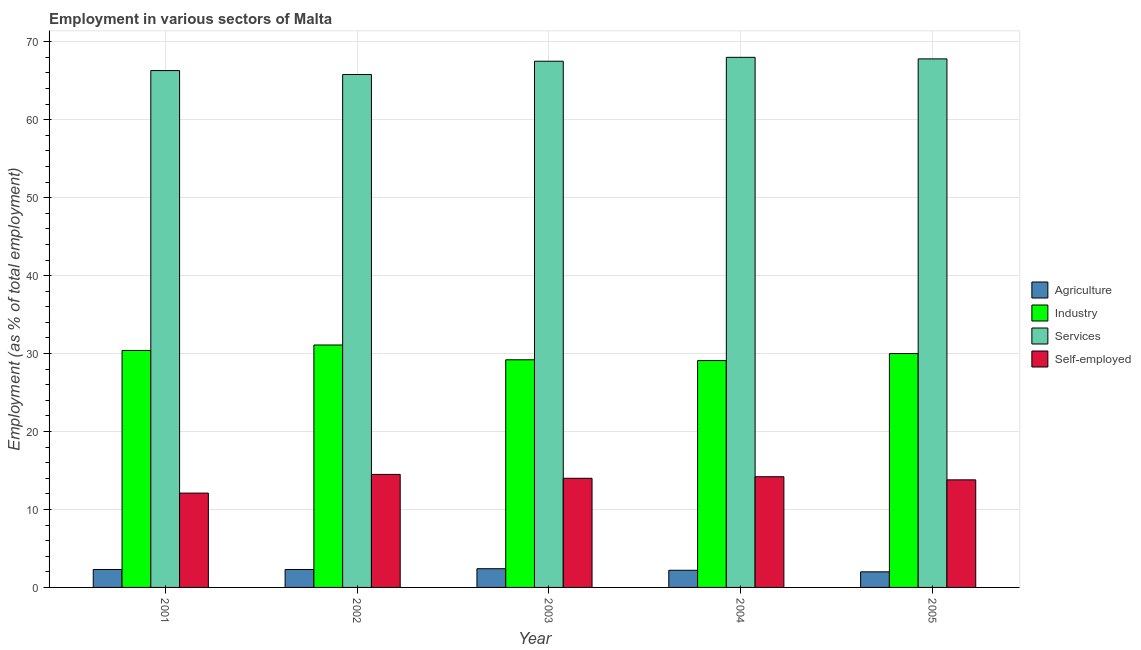How many different coloured bars are there?
Offer a terse response. 4. How many groups of bars are there?
Your response must be concise. 5. Are the number of bars per tick equal to the number of legend labels?
Provide a succinct answer. Yes. How many bars are there on the 2nd tick from the left?
Ensure brevity in your answer.  4. How many bars are there on the 1st tick from the right?
Your answer should be compact. 4. In how many cases, is the number of bars for a given year not equal to the number of legend labels?
Offer a very short reply. 0. What is the percentage of self employed workers in 2004?
Offer a very short reply. 14.2. Across all years, what is the maximum percentage of workers in industry?
Provide a succinct answer. 31.1. Across all years, what is the minimum percentage of self employed workers?
Your answer should be compact. 12.1. What is the total percentage of workers in services in the graph?
Make the answer very short. 335.4. What is the difference between the percentage of workers in agriculture in 2001 and that in 2005?
Your answer should be compact. 0.3. What is the difference between the percentage of workers in services in 2005 and the percentage of workers in industry in 2001?
Keep it short and to the point. 1.5. What is the average percentage of self employed workers per year?
Ensure brevity in your answer.  13.72. In the year 2003, what is the difference between the percentage of workers in agriculture and percentage of workers in industry?
Provide a short and direct response. 0. What is the ratio of the percentage of self employed workers in 2003 to that in 2004?
Offer a terse response. 0.99. Is the percentage of self employed workers in 2001 less than that in 2005?
Ensure brevity in your answer.  Yes. Is the difference between the percentage of workers in industry in 2001 and 2004 greater than the difference between the percentage of self employed workers in 2001 and 2004?
Offer a very short reply. No. What is the difference between the highest and the second highest percentage of self employed workers?
Your response must be concise. 0.3. What is the difference between the highest and the lowest percentage of workers in industry?
Ensure brevity in your answer.  2. What does the 2nd bar from the left in 2001 represents?
Keep it short and to the point. Industry. What does the 3rd bar from the right in 2003 represents?
Offer a very short reply. Industry. Is it the case that in every year, the sum of the percentage of workers in agriculture and percentage of workers in industry is greater than the percentage of workers in services?
Ensure brevity in your answer.  No. Are the values on the major ticks of Y-axis written in scientific E-notation?
Offer a very short reply. No. How are the legend labels stacked?
Provide a short and direct response. Vertical. What is the title of the graph?
Your answer should be compact. Employment in various sectors of Malta. What is the label or title of the X-axis?
Give a very brief answer. Year. What is the label or title of the Y-axis?
Make the answer very short. Employment (as % of total employment). What is the Employment (as % of total employment) in Agriculture in 2001?
Make the answer very short. 2.3. What is the Employment (as % of total employment) in Industry in 2001?
Your answer should be very brief. 30.4. What is the Employment (as % of total employment) of Services in 2001?
Your answer should be compact. 66.3. What is the Employment (as % of total employment) in Self-employed in 2001?
Offer a terse response. 12.1. What is the Employment (as % of total employment) in Agriculture in 2002?
Offer a terse response. 2.3. What is the Employment (as % of total employment) in Industry in 2002?
Offer a very short reply. 31.1. What is the Employment (as % of total employment) of Services in 2002?
Keep it short and to the point. 65.8. What is the Employment (as % of total employment) in Self-employed in 2002?
Give a very brief answer. 14.5. What is the Employment (as % of total employment) in Agriculture in 2003?
Offer a very short reply. 2.4. What is the Employment (as % of total employment) of Industry in 2003?
Offer a terse response. 29.2. What is the Employment (as % of total employment) of Services in 2003?
Provide a succinct answer. 67.5. What is the Employment (as % of total employment) of Agriculture in 2004?
Give a very brief answer. 2.2. What is the Employment (as % of total employment) of Industry in 2004?
Provide a short and direct response. 29.1. What is the Employment (as % of total employment) of Self-employed in 2004?
Offer a terse response. 14.2. What is the Employment (as % of total employment) of Industry in 2005?
Offer a terse response. 30. What is the Employment (as % of total employment) of Services in 2005?
Offer a terse response. 67.8. What is the Employment (as % of total employment) of Self-employed in 2005?
Keep it short and to the point. 13.8. Across all years, what is the maximum Employment (as % of total employment) in Agriculture?
Ensure brevity in your answer.  2.4. Across all years, what is the maximum Employment (as % of total employment) in Industry?
Your answer should be very brief. 31.1. Across all years, what is the minimum Employment (as % of total employment) in Agriculture?
Your response must be concise. 2. Across all years, what is the minimum Employment (as % of total employment) in Industry?
Provide a short and direct response. 29.1. Across all years, what is the minimum Employment (as % of total employment) in Services?
Make the answer very short. 65.8. Across all years, what is the minimum Employment (as % of total employment) of Self-employed?
Offer a very short reply. 12.1. What is the total Employment (as % of total employment) in Industry in the graph?
Offer a terse response. 149.8. What is the total Employment (as % of total employment) of Services in the graph?
Make the answer very short. 335.4. What is the total Employment (as % of total employment) in Self-employed in the graph?
Ensure brevity in your answer.  68.6. What is the difference between the Employment (as % of total employment) of Industry in 2001 and that in 2002?
Provide a short and direct response. -0.7. What is the difference between the Employment (as % of total employment) of Self-employed in 2001 and that in 2004?
Keep it short and to the point. -2.1. What is the difference between the Employment (as % of total employment) of Industry in 2001 and that in 2005?
Provide a succinct answer. 0.4. What is the difference between the Employment (as % of total employment) of Services in 2001 and that in 2005?
Your response must be concise. -1.5. What is the difference between the Employment (as % of total employment) of Self-employed in 2001 and that in 2005?
Make the answer very short. -1.7. What is the difference between the Employment (as % of total employment) in Agriculture in 2002 and that in 2003?
Your answer should be very brief. -0.1. What is the difference between the Employment (as % of total employment) in Services in 2002 and that in 2003?
Offer a terse response. -1.7. What is the difference between the Employment (as % of total employment) in Agriculture in 2002 and that in 2004?
Keep it short and to the point. 0.1. What is the difference between the Employment (as % of total employment) of Services in 2002 and that in 2004?
Your response must be concise. -2.2. What is the difference between the Employment (as % of total employment) in Self-employed in 2002 and that in 2004?
Give a very brief answer. 0.3. What is the difference between the Employment (as % of total employment) of Industry in 2002 and that in 2005?
Give a very brief answer. 1.1. What is the difference between the Employment (as % of total employment) in Services in 2002 and that in 2005?
Your response must be concise. -2. What is the difference between the Employment (as % of total employment) in Self-employed in 2002 and that in 2005?
Your answer should be very brief. 0.7. What is the difference between the Employment (as % of total employment) in Services in 2003 and that in 2004?
Make the answer very short. -0.5. What is the difference between the Employment (as % of total employment) of Self-employed in 2003 and that in 2004?
Keep it short and to the point. -0.2. What is the difference between the Employment (as % of total employment) in Agriculture in 2003 and that in 2005?
Provide a succinct answer. 0.4. What is the difference between the Employment (as % of total employment) in Self-employed in 2003 and that in 2005?
Keep it short and to the point. 0.2. What is the difference between the Employment (as % of total employment) of Services in 2004 and that in 2005?
Your answer should be compact. 0.2. What is the difference between the Employment (as % of total employment) in Agriculture in 2001 and the Employment (as % of total employment) in Industry in 2002?
Make the answer very short. -28.8. What is the difference between the Employment (as % of total employment) in Agriculture in 2001 and the Employment (as % of total employment) in Services in 2002?
Provide a succinct answer. -63.5. What is the difference between the Employment (as % of total employment) in Agriculture in 2001 and the Employment (as % of total employment) in Self-employed in 2002?
Keep it short and to the point. -12.2. What is the difference between the Employment (as % of total employment) in Industry in 2001 and the Employment (as % of total employment) in Services in 2002?
Provide a succinct answer. -35.4. What is the difference between the Employment (as % of total employment) in Industry in 2001 and the Employment (as % of total employment) in Self-employed in 2002?
Your answer should be compact. 15.9. What is the difference between the Employment (as % of total employment) of Services in 2001 and the Employment (as % of total employment) of Self-employed in 2002?
Provide a short and direct response. 51.8. What is the difference between the Employment (as % of total employment) of Agriculture in 2001 and the Employment (as % of total employment) of Industry in 2003?
Provide a succinct answer. -26.9. What is the difference between the Employment (as % of total employment) of Agriculture in 2001 and the Employment (as % of total employment) of Services in 2003?
Offer a terse response. -65.2. What is the difference between the Employment (as % of total employment) of Industry in 2001 and the Employment (as % of total employment) of Services in 2003?
Keep it short and to the point. -37.1. What is the difference between the Employment (as % of total employment) in Services in 2001 and the Employment (as % of total employment) in Self-employed in 2003?
Provide a short and direct response. 52.3. What is the difference between the Employment (as % of total employment) in Agriculture in 2001 and the Employment (as % of total employment) in Industry in 2004?
Give a very brief answer. -26.8. What is the difference between the Employment (as % of total employment) of Agriculture in 2001 and the Employment (as % of total employment) of Services in 2004?
Give a very brief answer. -65.7. What is the difference between the Employment (as % of total employment) in Agriculture in 2001 and the Employment (as % of total employment) in Self-employed in 2004?
Your response must be concise. -11.9. What is the difference between the Employment (as % of total employment) of Industry in 2001 and the Employment (as % of total employment) of Services in 2004?
Offer a terse response. -37.6. What is the difference between the Employment (as % of total employment) of Services in 2001 and the Employment (as % of total employment) of Self-employed in 2004?
Offer a very short reply. 52.1. What is the difference between the Employment (as % of total employment) of Agriculture in 2001 and the Employment (as % of total employment) of Industry in 2005?
Give a very brief answer. -27.7. What is the difference between the Employment (as % of total employment) of Agriculture in 2001 and the Employment (as % of total employment) of Services in 2005?
Keep it short and to the point. -65.5. What is the difference between the Employment (as % of total employment) in Industry in 2001 and the Employment (as % of total employment) in Services in 2005?
Offer a very short reply. -37.4. What is the difference between the Employment (as % of total employment) of Industry in 2001 and the Employment (as % of total employment) of Self-employed in 2005?
Provide a short and direct response. 16.6. What is the difference between the Employment (as % of total employment) of Services in 2001 and the Employment (as % of total employment) of Self-employed in 2005?
Your answer should be very brief. 52.5. What is the difference between the Employment (as % of total employment) of Agriculture in 2002 and the Employment (as % of total employment) of Industry in 2003?
Make the answer very short. -26.9. What is the difference between the Employment (as % of total employment) of Agriculture in 2002 and the Employment (as % of total employment) of Services in 2003?
Ensure brevity in your answer.  -65.2. What is the difference between the Employment (as % of total employment) in Agriculture in 2002 and the Employment (as % of total employment) in Self-employed in 2003?
Offer a terse response. -11.7. What is the difference between the Employment (as % of total employment) of Industry in 2002 and the Employment (as % of total employment) of Services in 2003?
Your response must be concise. -36.4. What is the difference between the Employment (as % of total employment) in Industry in 2002 and the Employment (as % of total employment) in Self-employed in 2003?
Your answer should be very brief. 17.1. What is the difference between the Employment (as % of total employment) of Services in 2002 and the Employment (as % of total employment) of Self-employed in 2003?
Your response must be concise. 51.8. What is the difference between the Employment (as % of total employment) in Agriculture in 2002 and the Employment (as % of total employment) in Industry in 2004?
Offer a terse response. -26.8. What is the difference between the Employment (as % of total employment) of Agriculture in 2002 and the Employment (as % of total employment) of Services in 2004?
Your answer should be very brief. -65.7. What is the difference between the Employment (as % of total employment) of Agriculture in 2002 and the Employment (as % of total employment) of Self-employed in 2004?
Offer a terse response. -11.9. What is the difference between the Employment (as % of total employment) in Industry in 2002 and the Employment (as % of total employment) in Services in 2004?
Provide a succinct answer. -36.9. What is the difference between the Employment (as % of total employment) in Industry in 2002 and the Employment (as % of total employment) in Self-employed in 2004?
Make the answer very short. 16.9. What is the difference between the Employment (as % of total employment) in Services in 2002 and the Employment (as % of total employment) in Self-employed in 2004?
Provide a short and direct response. 51.6. What is the difference between the Employment (as % of total employment) in Agriculture in 2002 and the Employment (as % of total employment) in Industry in 2005?
Give a very brief answer. -27.7. What is the difference between the Employment (as % of total employment) in Agriculture in 2002 and the Employment (as % of total employment) in Services in 2005?
Provide a short and direct response. -65.5. What is the difference between the Employment (as % of total employment) in Agriculture in 2002 and the Employment (as % of total employment) in Self-employed in 2005?
Your answer should be compact. -11.5. What is the difference between the Employment (as % of total employment) in Industry in 2002 and the Employment (as % of total employment) in Services in 2005?
Keep it short and to the point. -36.7. What is the difference between the Employment (as % of total employment) in Services in 2002 and the Employment (as % of total employment) in Self-employed in 2005?
Give a very brief answer. 52. What is the difference between the Employment (as % of total employment) of Agriculture in 2003 and the Employment (as % of total employment) of Industry in 2004?
Your answer should be compact. -26.7. What is the difference between the Employment (as % of total employment) of Agriculture in 2003 and the Employment (as % of total employment) of Services in 2004?
Offer a terse response. -65.6. What is the difference between the Employment (as % of total employment) of Agriculture in 2003 and the Employment (as % of total employment) of Self-employed in 2004?
Ensure brevity in your answer.  -11.8. What is the difference between the Employment (as % of total employment) in Industry in 2003 and the Employment (as % of total employment) in Services in 2004?
Make the answer very short. -38.8. What is the difference between the Employment (as % of total employment) in Industry in 2003 and the Employment (as % of total employment) in Self-employed in 2004?
Your answer should be very brief. 15. What is the difference between the Employment (as % of total employment) in Services in 2003 and the Employment (as % of total employment) in Self-employed in 2004?
Your answer should be very brief. 53.3. What is the difference between the Employment (as % of total employment) of Agriculture in 2003 and the Employment (as % of total employment) of Industry in 2005?
Make the answer very short. -27.6. What is the difference between the Employment (as % of total employment) of Agriculture in 2003 and the Employment (as % of total employment) of Services in 2005?
Ensure brevity in your answer.  -65.4. What is the difference between the Employment (as % of total employment) in Industry in 2003 and the Employment (as % of total employment) in Services in 2005?
Your response must be concise. -38.6. What is the difference between the Employment (as % of total employment) in Industry in 2003 and the Employment (as % of total employment) in Self-employed in 2005?
Give a very brief answer. 15.4. What is the difference between the Employment (as % of total employment) of Services in 2003 and the Employment (as % of total employment) of Self-employed in 2005?
Provide a succinct answer. 53.7. What is the difference between the Employment (as % of total employment) in Agriculture in 2004 and the Employment (as % of total employment) in Industry in 2005?
Ensure brevity in your answer.  -27.8. What is the difference between the Employment (as % of total employment) of Agriculture in 2004 and the Employment (as % of total employment) of Services in 2005?
Keep it short and to the point. -65.6. What is the difference between the Employment (as % of total employment) of Agriculture in 2004 and the Employment (as % of total employment) of Self-employed in 2005?
Your answer should be very brief. -11.6. What is the difference between the Employment (as % of total employment) in Industry in 2004 and the Employment (as % of total employment) in Services in 2005?
Your answer should be compact. -38.7. What is the difference between the Employment (as % of total employment) in Services in 2004 and the Employment (as % of total employment) in Self-employed in 2005?
Provide a short and direct response. 54.2. What is the average Employment (as % of total employment) of Agriculture per year?
Ensure brevity in your answer.  2.24. What is the average Employment (as % of total employment) in Industry per year?
Offer a terse response. 29.96. What is the average Employment (as % of total employment) of Services per year?
Give a very brief answer. 67.08. What is the average Employment (as % of total employment) of Self-employed per year?
Make the answer very short. 13.72. In the year 2001, what is the difference between the Employment (as % of total employment) in Agriculture and Employment (as % of total employment) in Industry?
Your answer should be compact. -28.1. In the year 2001, what is the difference between the Employment (as % of total employment) in Agriculture and Employment (as % of total employment) in Services?
Your response must be concise. -64. In the year 2001, what is the difference between the Employment (as % of total employment) of Industry and Employment (as % of total employment) of Services?
Keep it short and to the point. -35.9. In the year 2001, what is the difference between the Employment (as % of total employment) in Services and Employment (as % of total employment) in Self-employed?
Provide a short and direct response. 54.2. In the year 2002, what is the difference between the Employment (as % of total employment) in Agriculture and Employment (as % of total employment) in Industry?
Provide a short and direct response. -28.8. In the year 2002, what is the difference between the Employment (as % of total employment) of Agriculture and Employment (as % of total employment) of Services?
Your answer should be very brief. -63.5. In the year 2002, what is the difference between the Employment (as % of total employment) of Agriculture and Employment (as % of total employment) of Self-employed?
Your answer should be compact. -12.2. In the year 2002, what is the difference between the Employment (as % of total employment) of Industry and Employment (as % of total employment) of Services?
Provide a succinct answer. -34.7. In the year 2002, what is the difference between the Employment (as % of total employment) in Industry and Employment (as % of total employment) in Self-employed?
Your answer should be compact. 16.6. In the year 2002, what is the difference between the Employment (as % of total employment) in Services and Employment (as % of total employment) in Self-employed?
Your response must be concise. 51.3. In the year 2003, what is the difference between the Employment (as % of total employment) of Agriculture and Employment (as % of total employment) of Industry?
Give a very brief answer. -26.8. In the year 2003, what is the difference between the Employment (as % of total employment) in Agriculture and Employment (as % of total employment) in Services?
Make the answer very short. -65.1. In the year 2003, what is the difference between the Employment (as % of total employment) in Industry and Employment (as % of total employment) in Services?
Provide a succinct answer. -38.3. In the year 2003, what is the difference between the Employment (as % of total employment) of Services and Employment (as % of total employment) of Self-employed?
Your answer should be compact. 53.5. In the year 2004, what is the difference between the Employment (as % of total employment) in Agriculture and Employment (as % of total employment) in Industry?
Offer a very short reply. -26.9. In the year 2004, what is the difference between the Employment (as % of total employment) of Agriculture and Employment (as % of total employment) of Services?
Provide a short and direct response. -65.8. In the year 2004, what is the difference between the Employment (as % of total employment) in Agriculture and Employment (as % of total employment) in Self-employed?
Provide a succinct answer. -12. In the year 2004, what is the difference between the Employment (as % of total employment) in Industry and Employment (as % of total employment) in Services?
Make the answer very short. -38.9. In the year 2004, what is the difference between the Employment (as % of total employment) in Industry and Employment (as % of total employment) in Self-employed?
Keep it short and to the point. 14.9. In the year 2004, what is the difference between the Employment (as % of total employment) in Services and Employment (as % of total employment) in Self-employed?
Keep it short and to the point. 53.8. In the year 2005, what is the difference between the Employment (as % of total employment) of Agriculture and Employment (as % of total employment) of Services?
Ensure brevity in your answer.  -65.8. In the year 2005, what is the difference between the Employment (as % of total employment) of Agriculture and Employment (as % of total employment) of Self-employed?
Ensure brevity in your answer.  -11.8. In the year 2005, what is the difference between the Employment (as % of total employment) in Industry and Employment (as % of total employment) in Services?
Your answer should be very brief. -37.8. What is the ratio of the Employment (as % of total employment) in Agriculture in 2001 to that in 2002?
Your answer should be compact. 1. What is the ratio of the Employment (as % of total employment) in Industry in 2001 to that in 2002?
Offer a terse response. 0.98. What is the ratio of the Employment (as % of total employment) in Services in 2001 to that in 2002?
Your answer should be very brief. 1.01. What is the ratio of the Employment (as % of total employment) in Self-employed in 2001 to that in 2002?
Your answer should be compact. 0.83. What is the ratio of the Employment (as % of total employment) in Industry in 2001 to that in 2003?
Offer a very short reply. 1.04. What is the ratio of the Employment (as % of total employment) in Services in 2001 to that in 2003?
Ensure brevity in your answer.  0.98. What is the ratio of the Employment (as % of total employment) of Self-employed in 2001 to that in 2003?
Provide a short and direct response. 0.86. What is the ratio of the Employment (as % of total employment) of Agriculture in 2001 to that in 2004?
Provide a short and direct response. 1.05. What is the ratio of the Employment (as % of total employment) in Industry in 2001 to that in 2004?
Your answer should be very brief. 1.04. What is the ratio of the Employment (as % of total employment) in Services in 2001 to that in 2004?
Offer a very short reply. 0.97. What is the ratio of the Employment (as % of total employment) in Self-employed in 2001 to that in 2004?
Give a very brief answer. 0.85. What is the ratio of the Employment (as % of total employment) in Agriculture in 2001 to that in 2005?
Your response must be concise. 1.15. What is the ratio of the Employment (as % of total employment) in Industry in 2001 to that in 2005?
Your answer should be very brief. 1.01. What is the ratio of the Employment (as % of total employment) in Services in 2001 to that in 2005?
Your response must be concise. 0.98. What is the ratio of the Employment (as % of total employment) of Self-employed in 2001 to that in 2005?
Keep it short and to the point. 0.88. What is the ratio of the Employment (as % of total employment) in Agriculture in 2002 to that in 2003?
Keep it short and to the point. 0.96. What is the ratio of the Employment (as % of total employment) of Industry in 2002 to that in 2003?
Provide a short and direct response. 1.07. What is the ratio of the Employment (as % of total employment) of Services in 2002 to that in 2003?
Ensure brevity in your answer.  0.97. What is the ratio of the Employment (as % of total employment) in Self-employed in 2002 to that in 2003?
Your answer should be very brief. 1.04. What is the ratio of the Employment (as % of total employment) in Agriculture in 2002 to that in 2004?
Your response must be concise. 1.05. What is the ratio of the Employment (as % of total employment) of Industry in 2002 to that in 2004?
Your answer should be compact. 1.07. What is the ratio of the Employment (as % of total employment) in Services in 2002 to that in 2004?
Give a very brief answer. 0.97. What is the ratio of the Employment (as % of total employment) of Self-employed in 2002 to that in 2004?
Ensure brevity in your answer.  1.02. What is the ratio of the Employment (as % of total employment) of Agriculture in 2002 to that in 2005?
Your answer should be very brief. 1.15. What is the ratio of the Employment (as % of total employment) of Industry in 2002 to that in 2005?
Ensure brevity in your answer.  1.04. What is the ratio of the Employment (as % of total employment) of Services in 2002 to that in 2005?
Provide a succinct answer. 0.97. What is the ratio of the Employment (as % of total employment) in Self-employed in 2002 to that in 2005?
Keep it short and to the point. 1.05. What is the ratio of the Employment (as % of total employment) of Self-employed in 2003 to that in 2004?
Give a very brief answer. 0.99. What is the ratio of the Employment (as % of total employment) in Industry in 2003 to that in 2005?
Offer a very short reply. 0.97. What is the ratio of the Employment (as % of total employment) of Services in 2003 to that in 2005?
Your answer should be compact. 1. What is the ratio of the Employment (as % of total employment) in Self-employed in 2003 to that in 2005?
Offer a very short reply. 1.01. What is the ratio of the Employment (as % of total employment) in Agriculture in 2004 to that in 2005?
Offer a very short reply. 1.1. What is the ratio of the Employment (as % of total employment) of Industry in 2004 to that in 2005?
Your answer should be compact. 0.97. What is the ratio of the Employment (as % of total employment) of Services in 2004 to that in 2005?
Give a very brief answer. 1. What is the difference between the highest and the second highest Employment (as % of total employment) of Services?
Offer a terse response. 0.2. What is the difference between the highest and the second highest Employment (as % of total employment) in Self-employed?
Your answer should be compact. 0.3. What is the difference between the highest and the lowest Employment (as % of total employment) in Agriculture?
Your answer should be very brief. 0.4. 